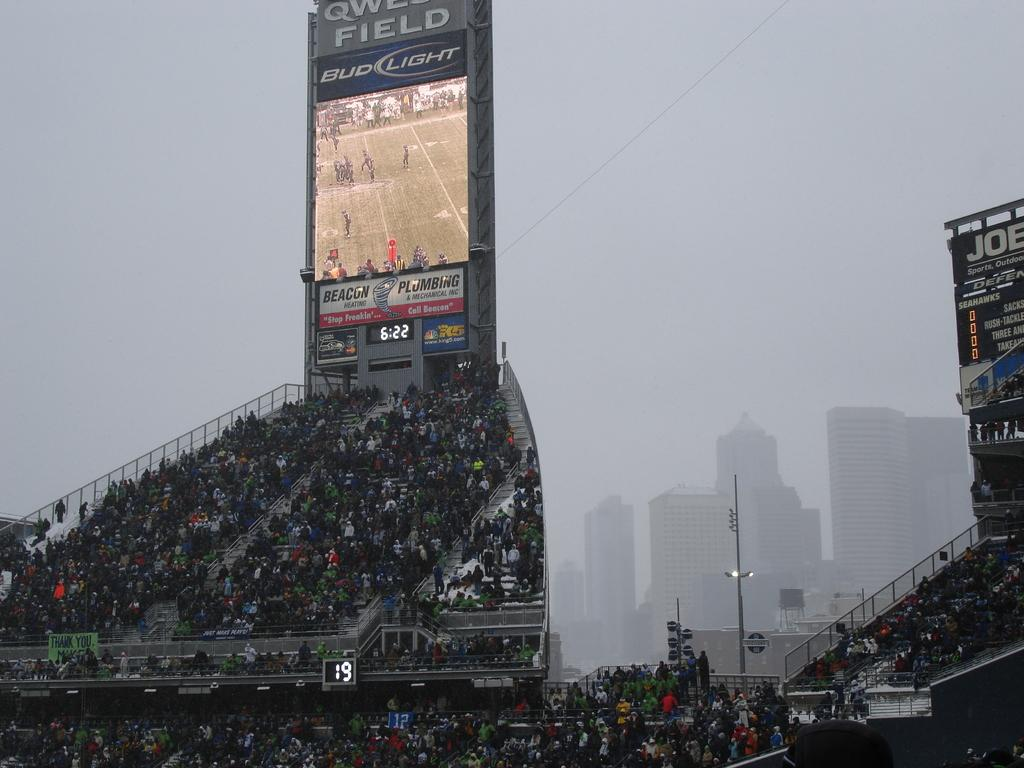<image>
Share a concise interpretation of the image provided. It's 6:22 at the stadium sponsored by bud light that starts with a Q. 